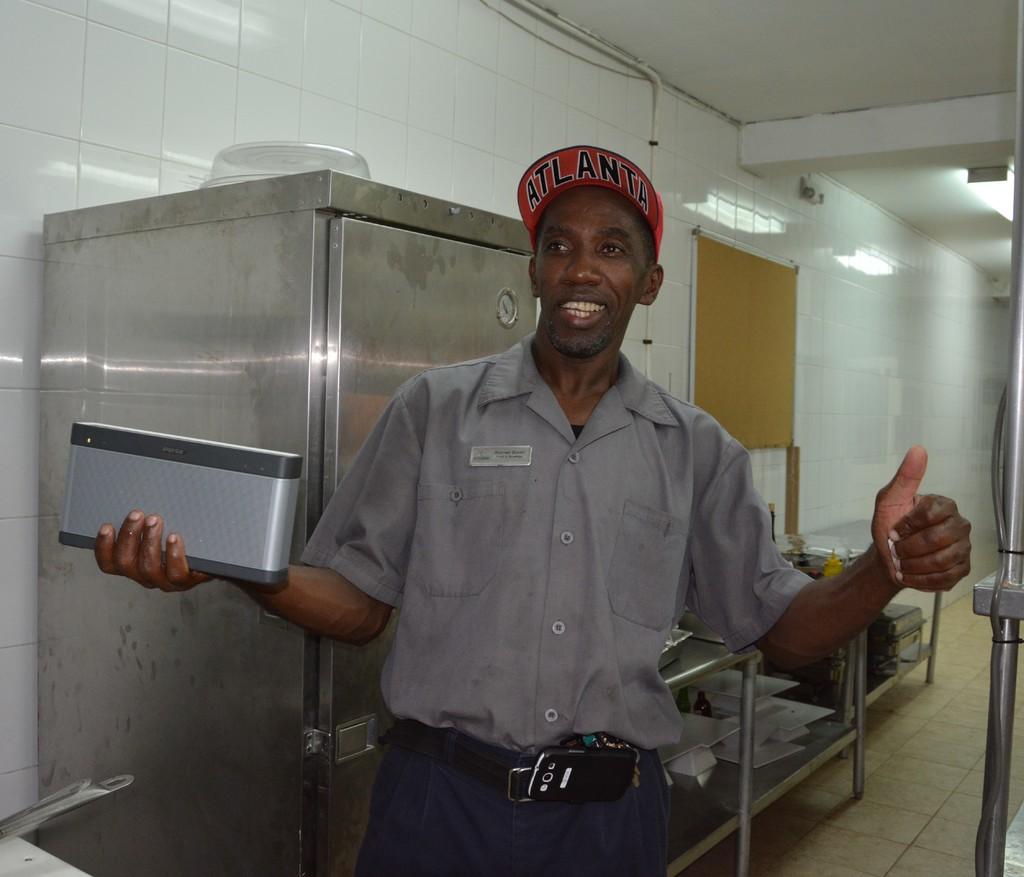What city is on his hat?
Your response must be concise. Atlanta. What does his hat say?
Your response must be concise. Atlanta. 